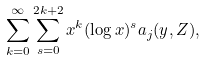Convert formula to latex. <formula><loc_0><loc_0><loc_500><loc_500>\sum _ { k = 0 } ^ { \infty } \sum _ { s = 0 } ^ { 2 k + 2 } x ^ { k } ( \log x ) ^ { s } a _ { j } ( y , Z ) ,</formula> 